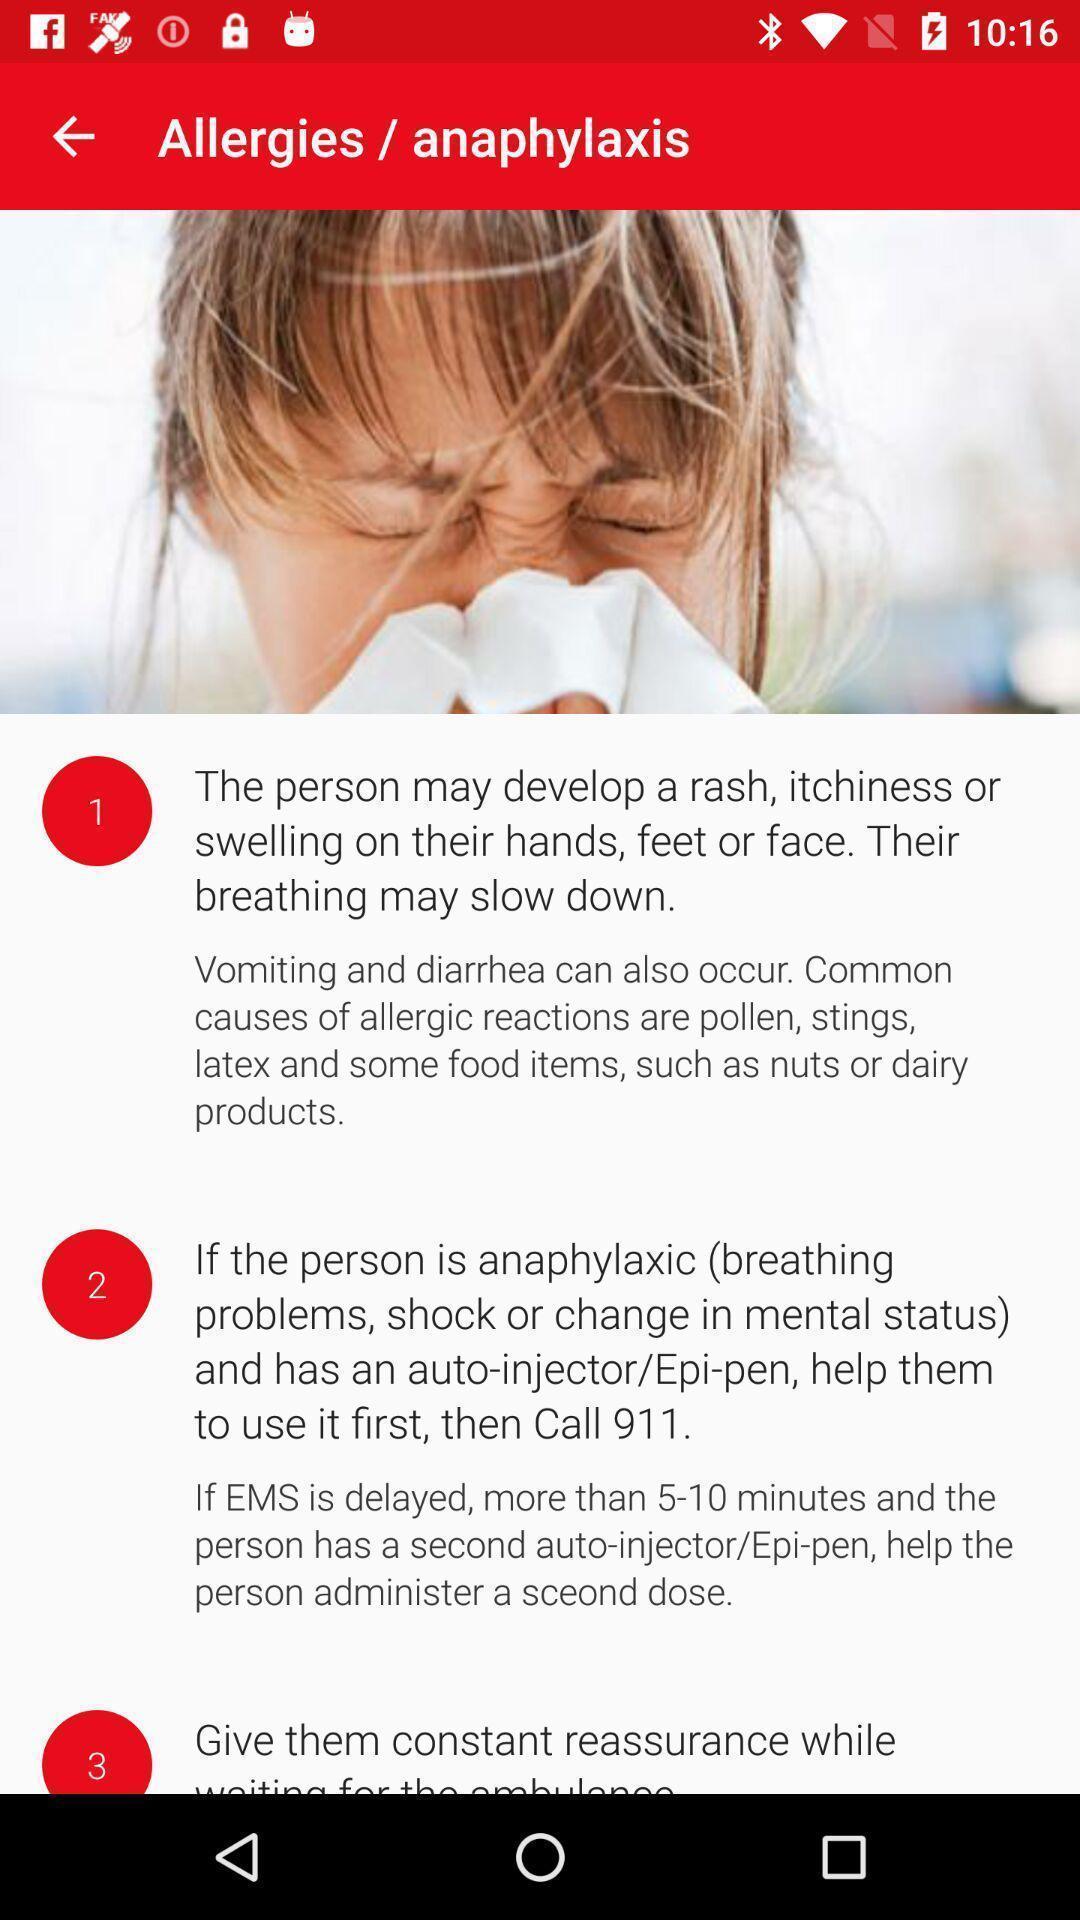What is the overall content of this screenshot? Screen shows symptoms of allergies. 